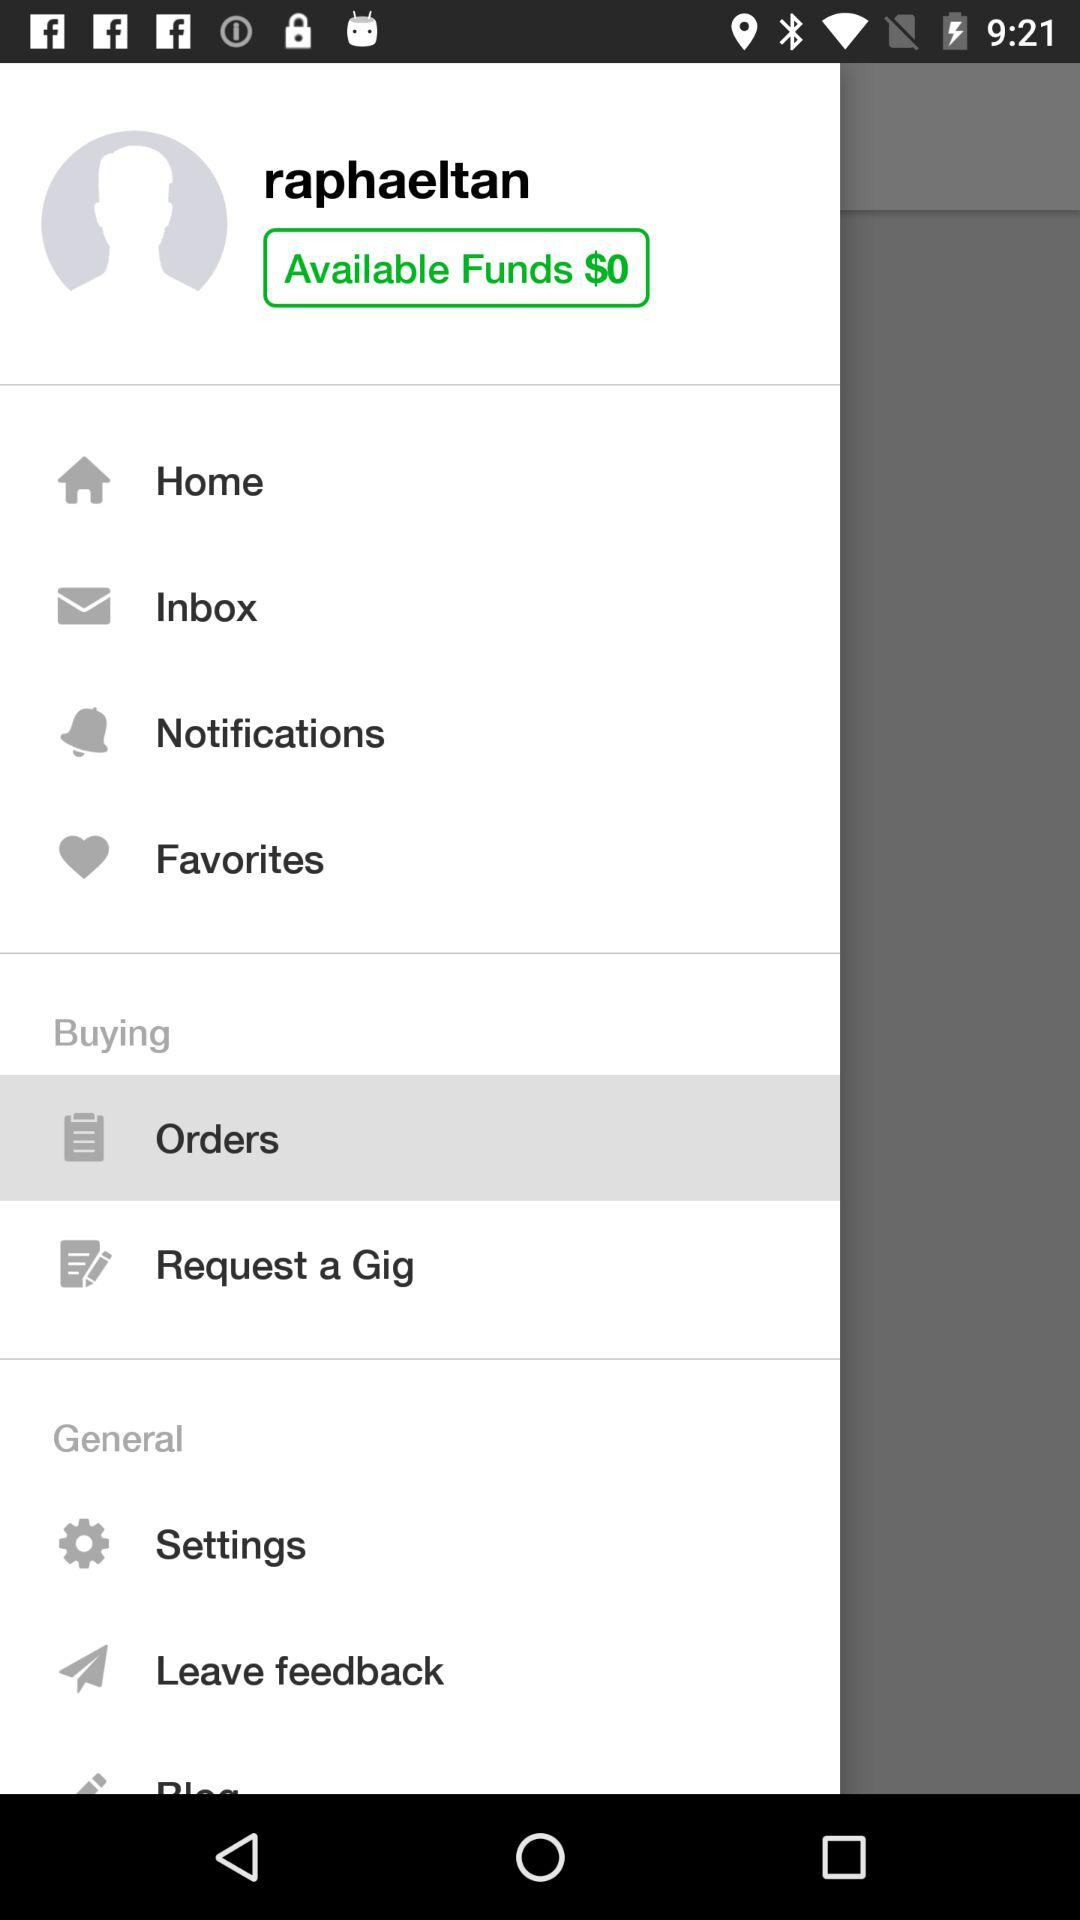How many notifications are there in the inbox?
When the provided information is insufficient, respond with <no answer>. <no answer> 